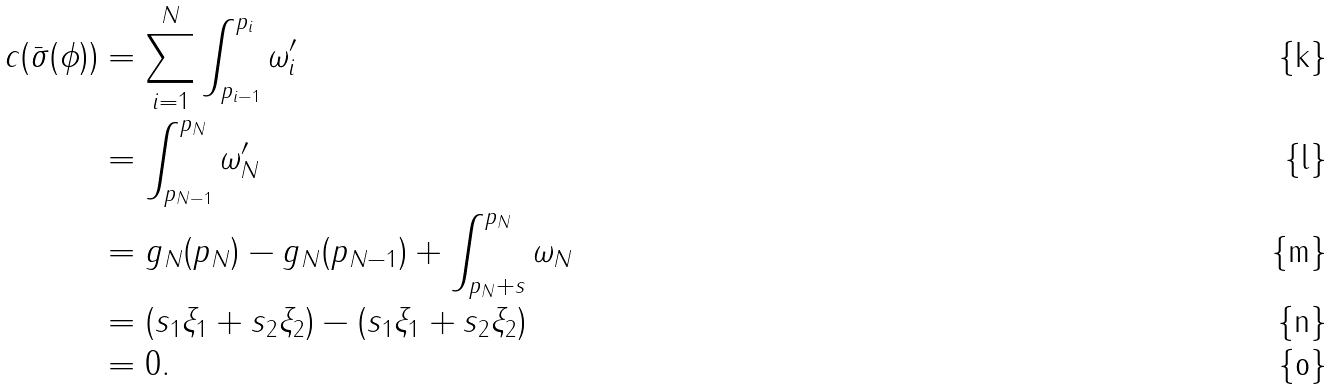<formula> <loc_0><loc_0><loc_500><loc_500>c ( \bar { \sigma } ( \phi ) ) & = \sum _ { i = 1 } ^ { N } \int _ { p _ { i - 1 } } ^ { p _ { i } } \omega _ { i } ^ { \prime } \\ & = \int _ { p _ { N - 1 } } ^ { p _ { N } } \omega _ { N } ^ { \prime } \\ & = g _ { N } ( p _ { N } ) - g _ { N } ( p _ { N - 1 } ) + \int _ { p _ { N } + s } ^ { p _ { N } } \omega _ { N } \\ & = ( s _ { 1 } \xi _ { 1 } + s _ { 2 } \xi _ { 2 } ) - ( s _ { 1 } \xi _ { 1 } + s _ { 2 } \xi _ { 2 } ) \\ & = 0 .</formula> 